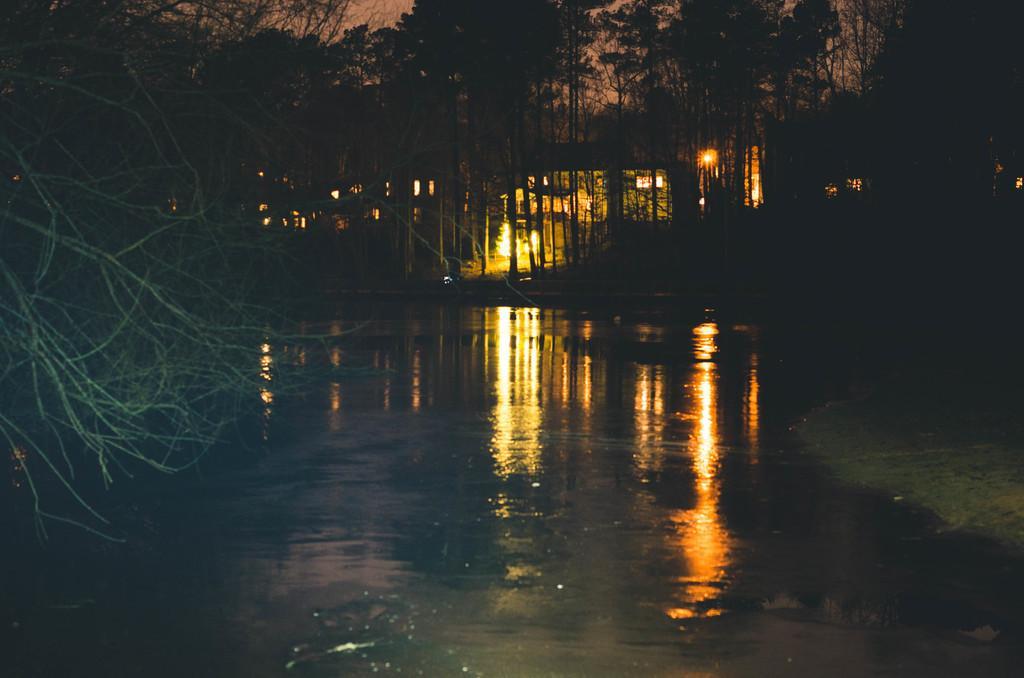Can you describe this image briefly? In this image we can see trees, lights and other objects. In the background of the image there is the sky. On the left side of the image there is the tree. At the bottom of the image there is water. On the water we can see some reflections. 